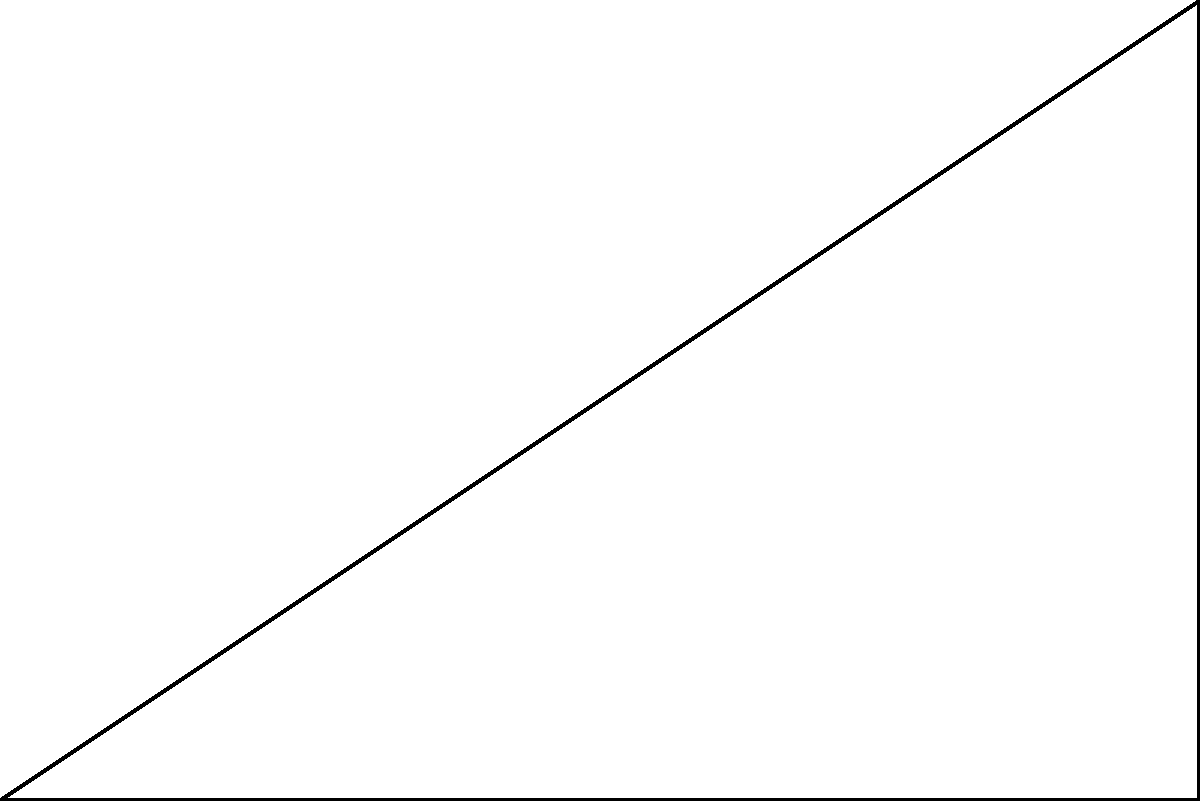In your algorithm for generating constructed languages, you're implementing a feature that rotates phoneme patterns in a 2D coordinate system. Given the original coordinate system $(x,y)$ and a new rotated coordinate system $(x',y')$ as shown in the figure, where the rotation angle is $\theta$, express $\sin(\alpha)$ in terms of $\sin(\alpha-\theta)$ and $\cos(\alpha-\theta)$, where $\alpha$ is an arbitrary angle in the original coordinate system. Let's approach this step-by-step:

1) First, recall the rotation formulas for converting between coordinate systems:
   $$x = x' \cos\theta - y' \sin\theta$$
   $$y = x' \sin\theta + y' \cos\theta$$

2) In the original coordinate system, we can express a point in terms of $\sin\alpha$ and $\cos\alpha$:
   $$x = r \cos\alpha$$
   $$y = r \sin\alpha$$
   where $r$ is the distance from the origin.

3) In the rotated coordinate system, we can express the same point in terms of $\sin(\alpha-\theta)$ and $\cos(\alpha-\theta)$:
   $$x' = r \cos(\alpha-\theta)$$
   $$y' = r \sin(\alpha-\theta)$$

4) Now, let's substitute the rotated coordinates into the rotation formula for $y$:
   $$y = x' \sin\theta + y' \cos\theta$$
   $$r \sin\alpha = r \cos(\alpha-\theta) \sin\theta + r \sin(\alpha-\theta) \cos\theta$$

5) Divide both sides by $r$:
   $$\sin\alpha = \cos(\alpha-\theta) \sin\theta + \sin(\alpha-\theta) \cos\theta$$

6) This is our final expression for $\sin\alpha$ in terms of $\sin(\alpha-\theta)$ and $\cos(\alpha-\theta)$.
Answer: $\sin\alpha = \cos(\alpha-\theta) \sin\theta + \sin(\alpha-\theta) \cos\theta$ 